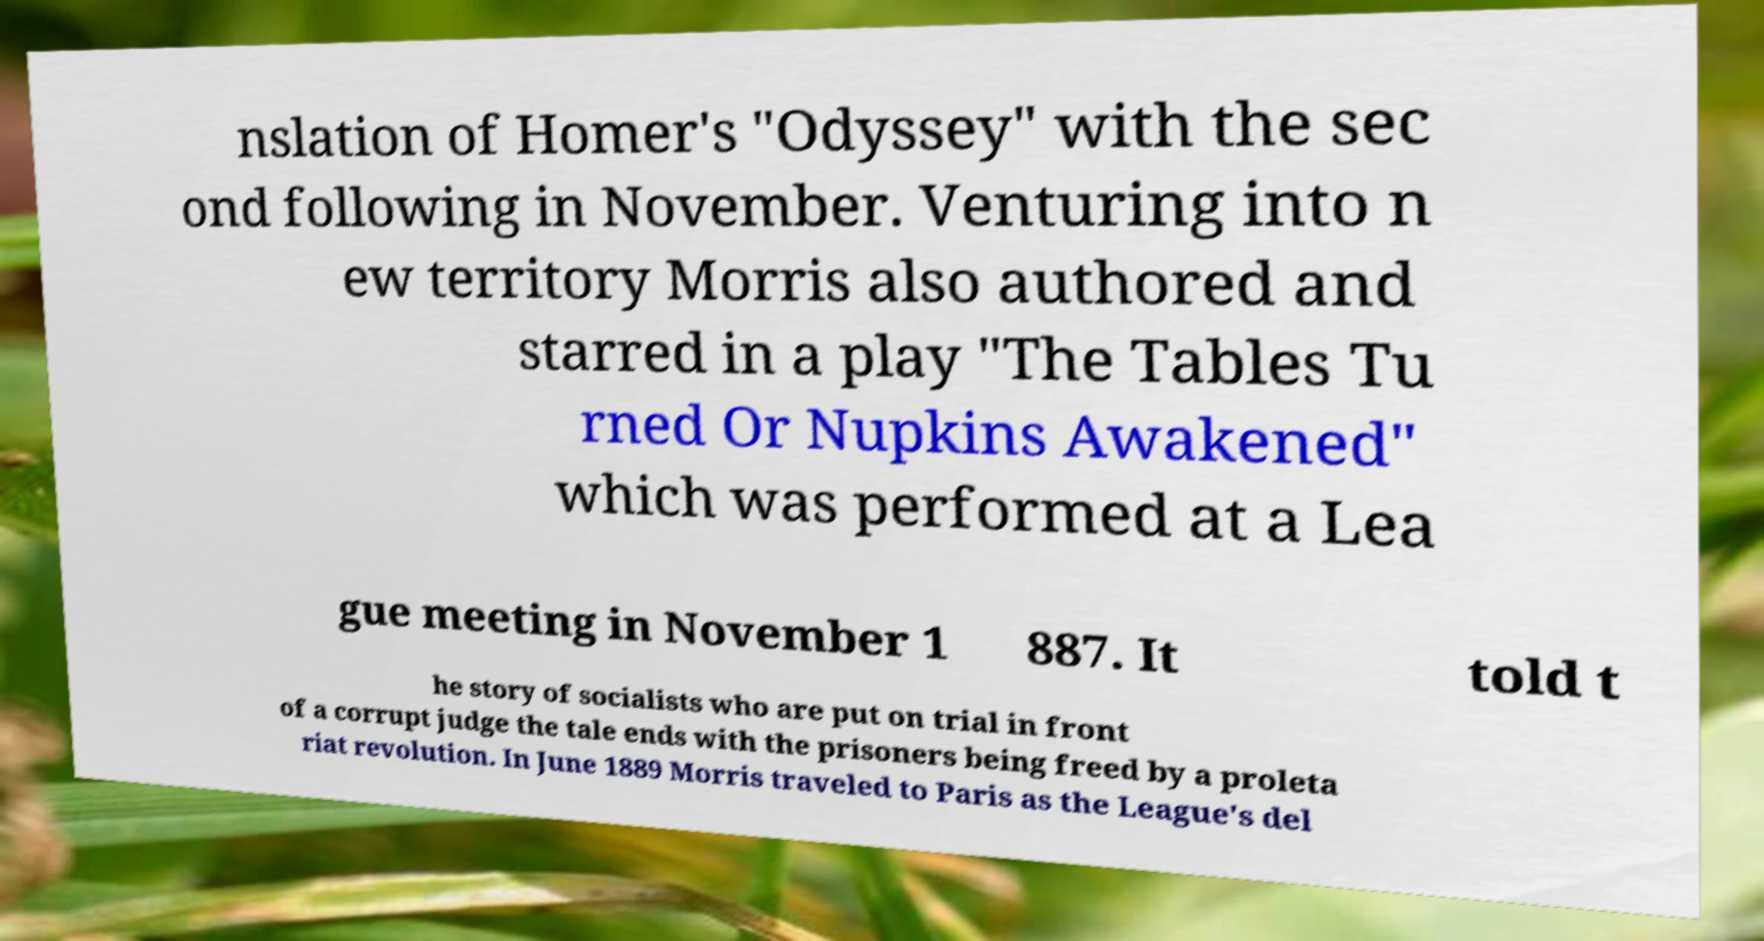Could you extract and type out the text from this image? nslation of Homer's "Odyssey" with the sec ond following in November. Venturing into n ew territory Morris also authored and starred in a play "The Tables Tu rned Or Nupkins Awakened" which was performed at a Lea gue meeting in November 1 887. It told t he story of socialists who are put on trial in front of a corrupt judge the tale ends with the prisoners being freed by a proleta riat revolution. In June 1889 Morris traveled to Paris as the League's del 